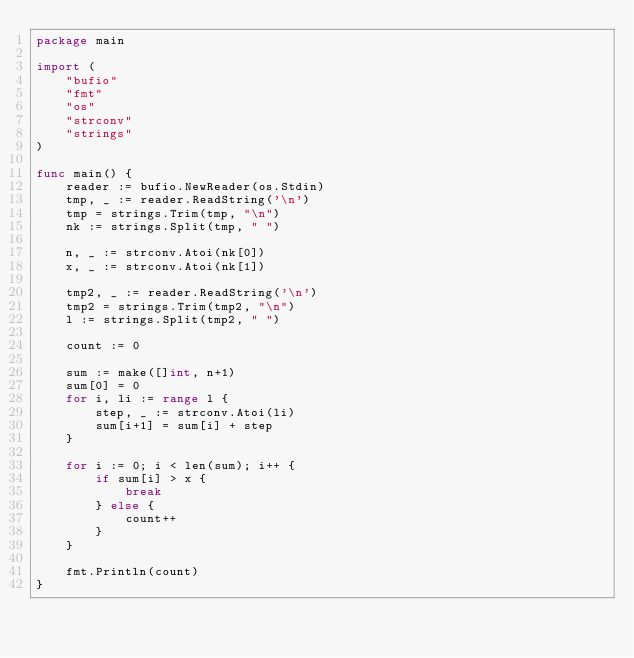<code> <loc_0><loc_0><loc_500><loc_500><_Go_>package main

import (
	"bufio"
	"fmt"
	"os"
	"strconv"
	"strings"
)

func main() {
	reader := bufio.NewReader(os.Stdin)
	tmp, _ := reader.ReadString('\n')
	tmp = strings.Trim(tmp, "\n")
	nk := strings.Split(tmp, " ")

	n, _ := strconv.Atoi(nk[0])
	x, _ := strconv.Atoi(nk[1])

	tmp2, _ := reader.ReadString('\n')
	tmp2 = strings.Trim(tmp2, "\n")
	l := strings.Split(tmp2, " ")

	count := 0

	sum := make([]int, n+1)
	sum[0] = 0
	for i, li := range l {
		step, _ := strconv.Atoi(li)
		sum[i+1] = sum[i] + step
	}

	for i := 0; i < len(sum); i++ {
		if sum[i] > x {
			break
		} else {
			count++
		}
	}

	fmt.Println(count)
}
</code> 